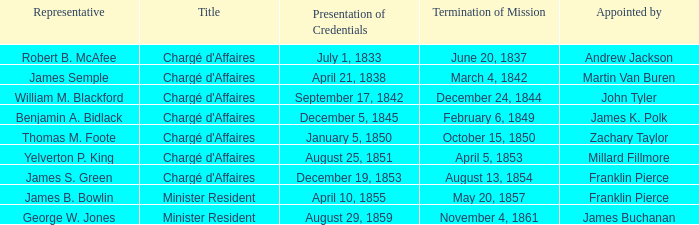What title possesses a conclusion of mission for august 13, 1854? Chargé d'Affaires. 